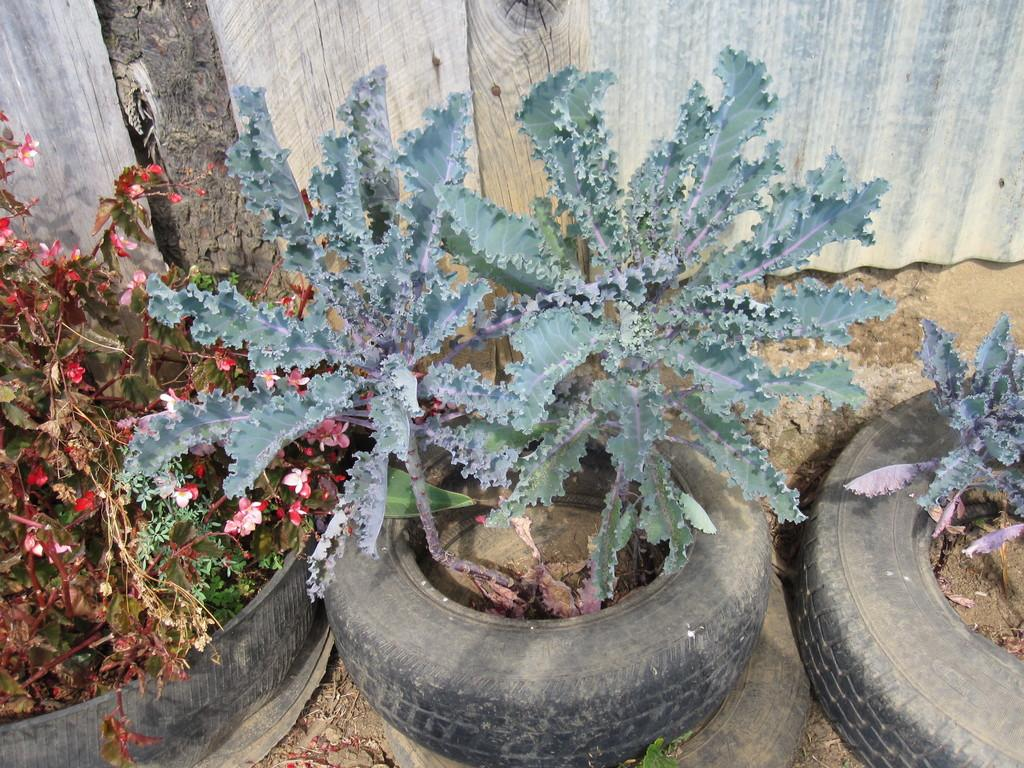What object is the main focus of the image? There is a tire in the image. What is growing inside the tire? There are plants and flowers in the tire. What type of terrain is visible in the image? There is sand visible in the image. What can be seen at the back of the image? There appears to be a shutter at the back of the image. How many cows are grazing in the sand in the image? There are no cows present in the image; it features a tire with plants and flowers, sand, and a shutter. What is the answer to the question about the tire in the image? There is no specific question about the tire in the image, so there is no answer to provide. 